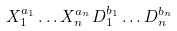<formula> <loc_0><loc_0><loc_500><loc_500>X _ { 1 } ^ { a _ { 1 } } \dots X _ { n } ^ { a _ { n } } D _ { 1 } ^ { b _ { 1 } } \dots D _ { n } ^ { b _ { n } }</formula> 